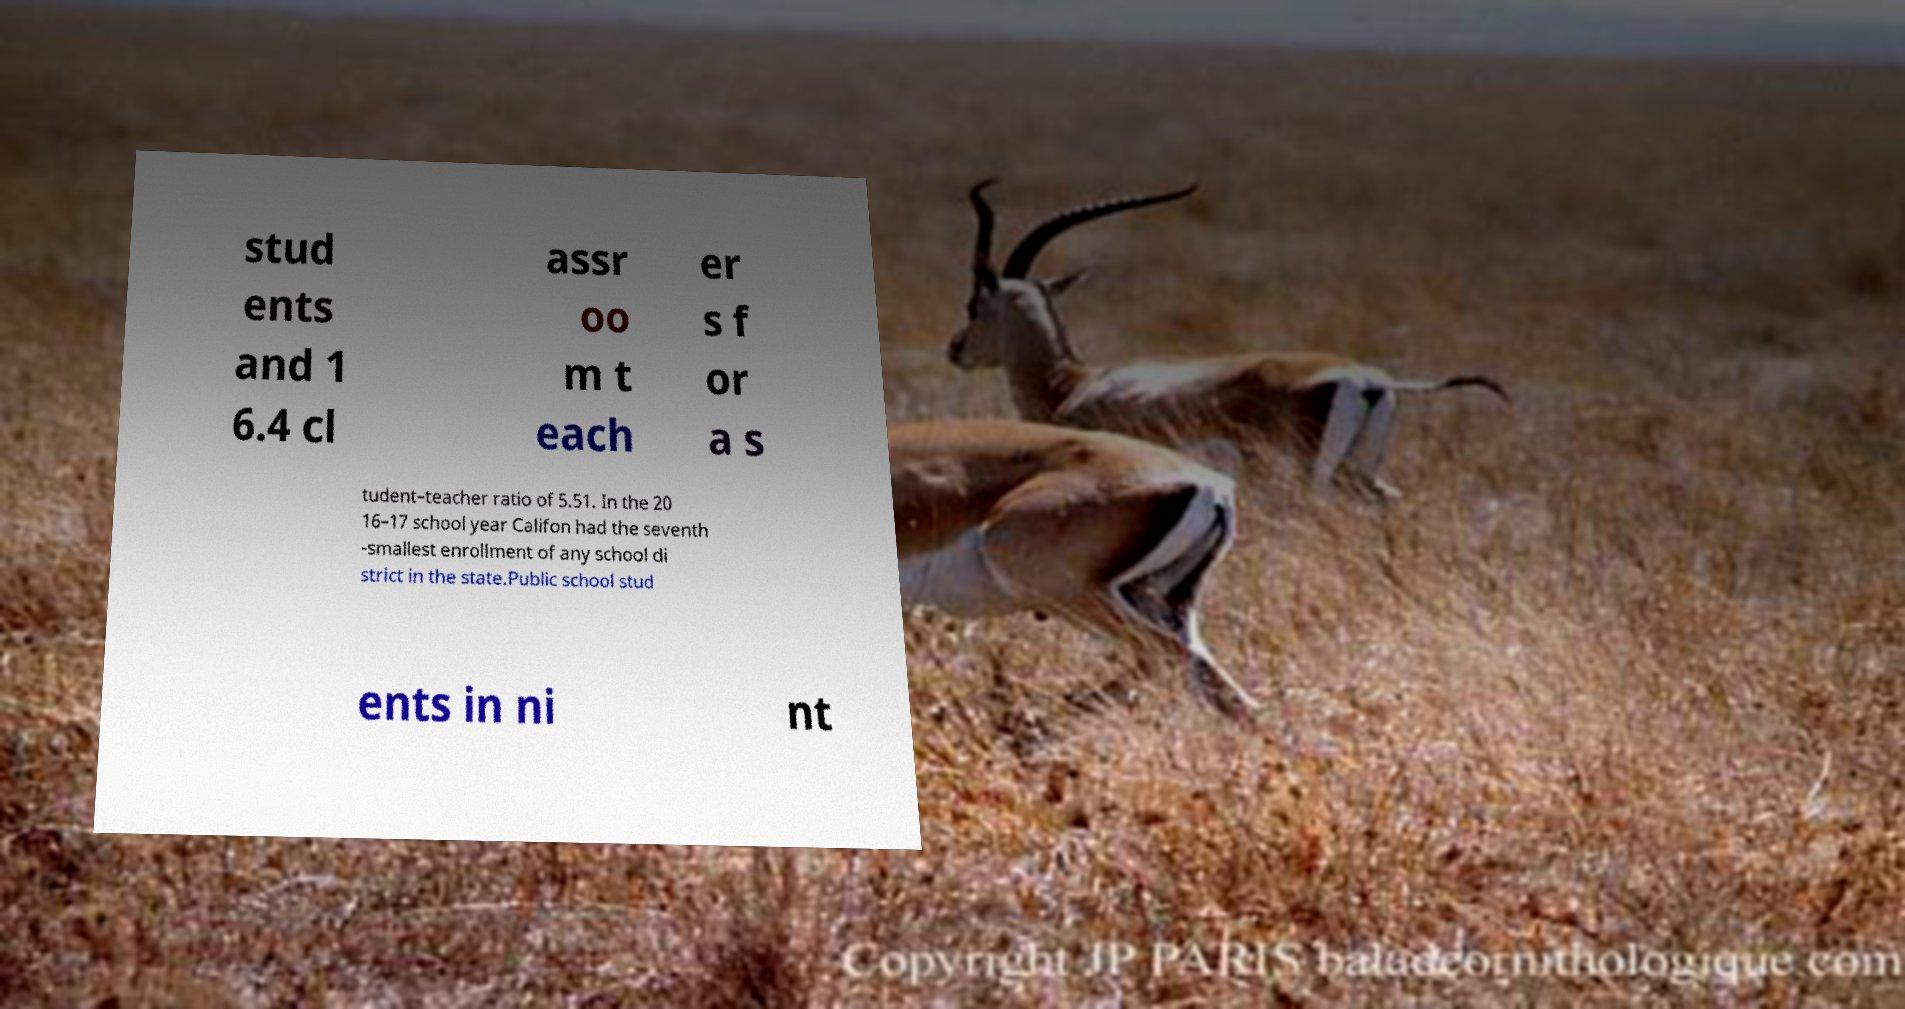What messages or text are displayed in this image? I need them in a readable, typed format. stud ents and 1 6.4 cl assr oo m t each er s f or a s tudent–teacher ratio of 5.51. In the 20 16–17 school year Califon had the seventh -smallest enrollment of any school di strict in the state.Public school stud ents in ni nt 